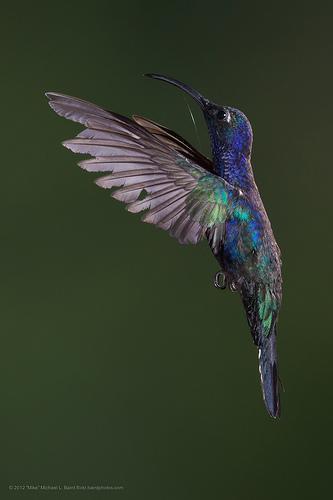How many birds are shown?
Give a very brief answer. 1. 